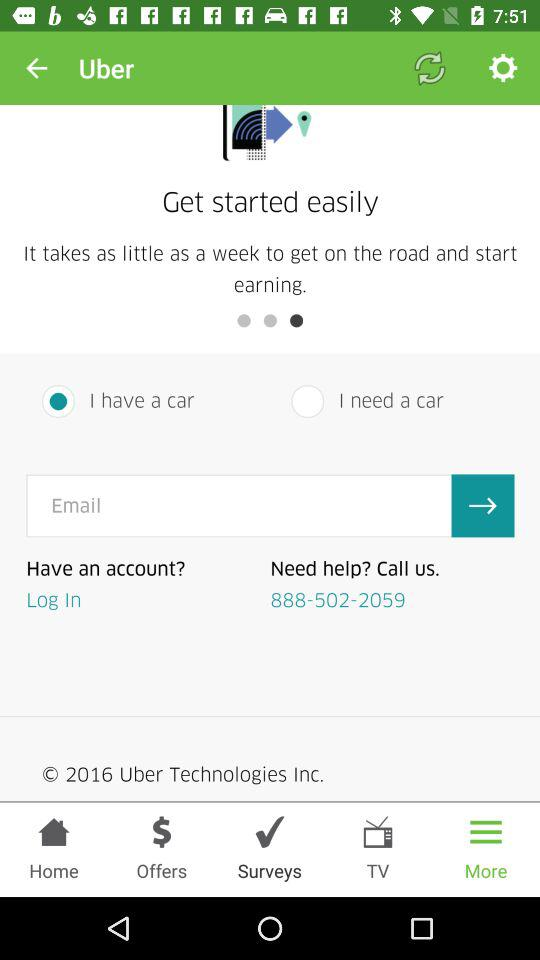What is the application name? The application name is "Uber". 